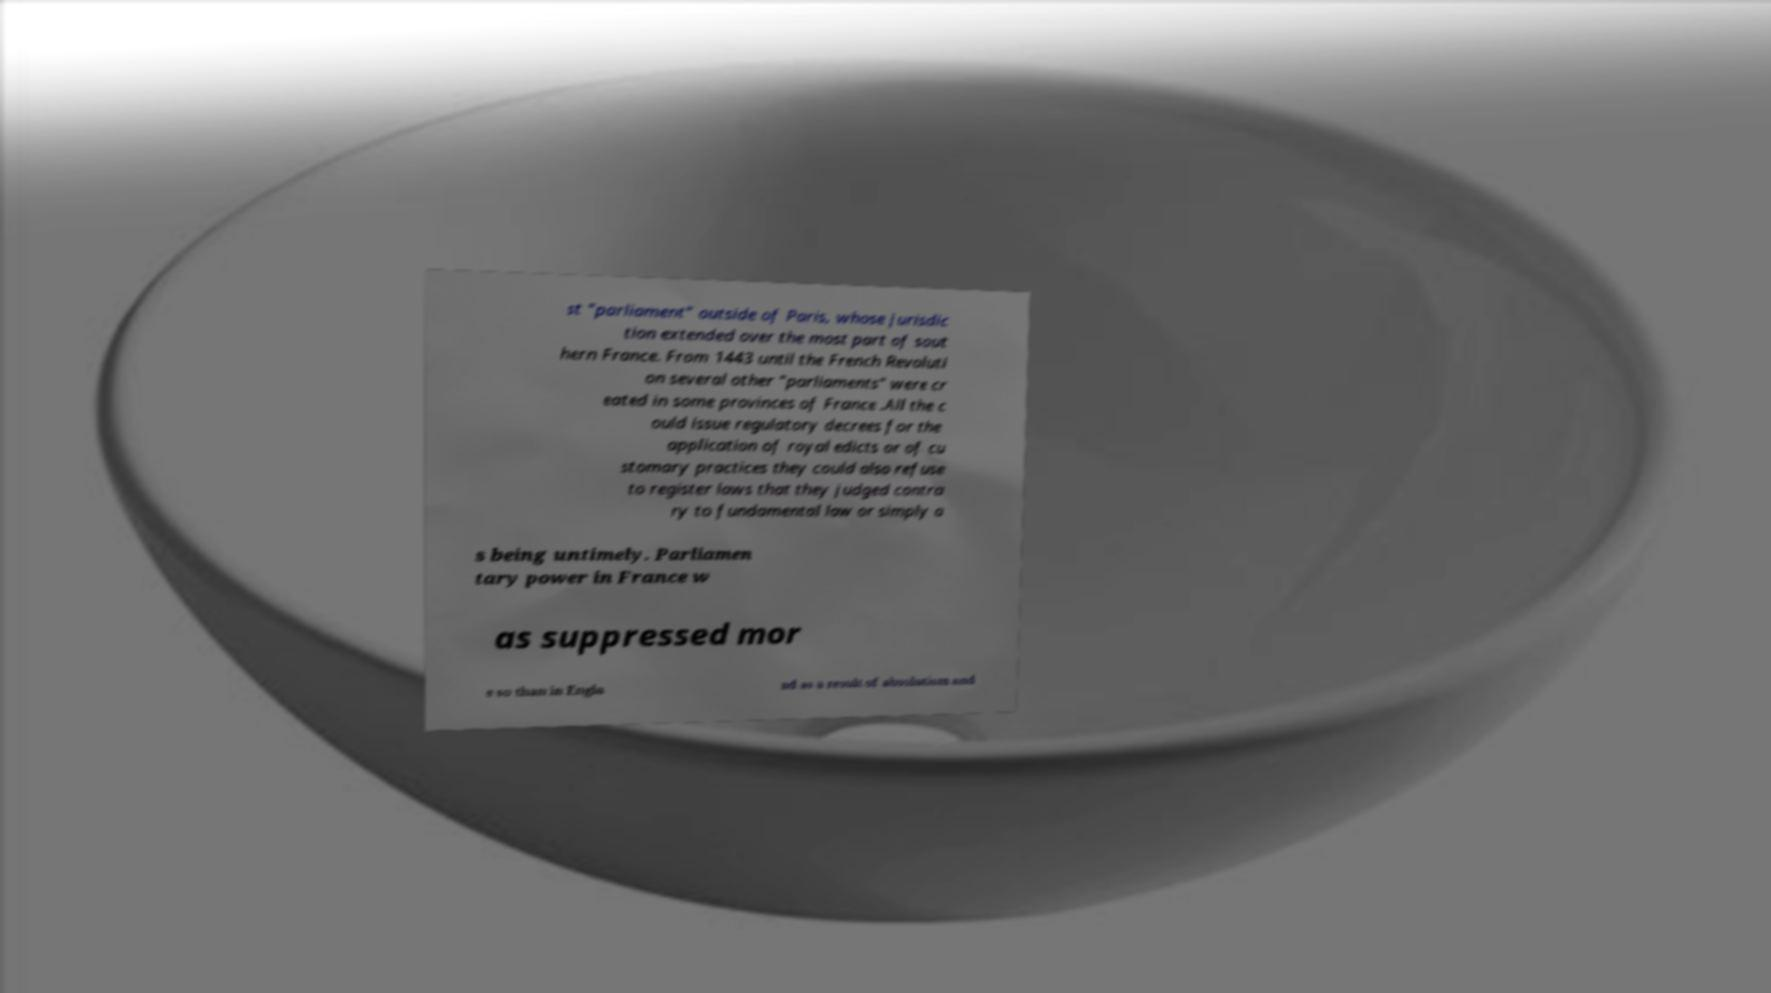Please read and relay the text visible in this image. What does it say? st "parliament" outside of Paris, whose jurisdic tion extended over the most part of sout hern France. From 1443 until the French Revoluti on several other "parliaments" were cr eated in some provinces of France .All the c ould issue regulatory decrees for the application of royal edicts or of cu stomary practices they could also refuse to register laws that they judged contra ry to fundamental law or simply a s being untimely. Parliamen tary power in France w as suppressed mor e so than in Engla nd as a result of absolutism and 